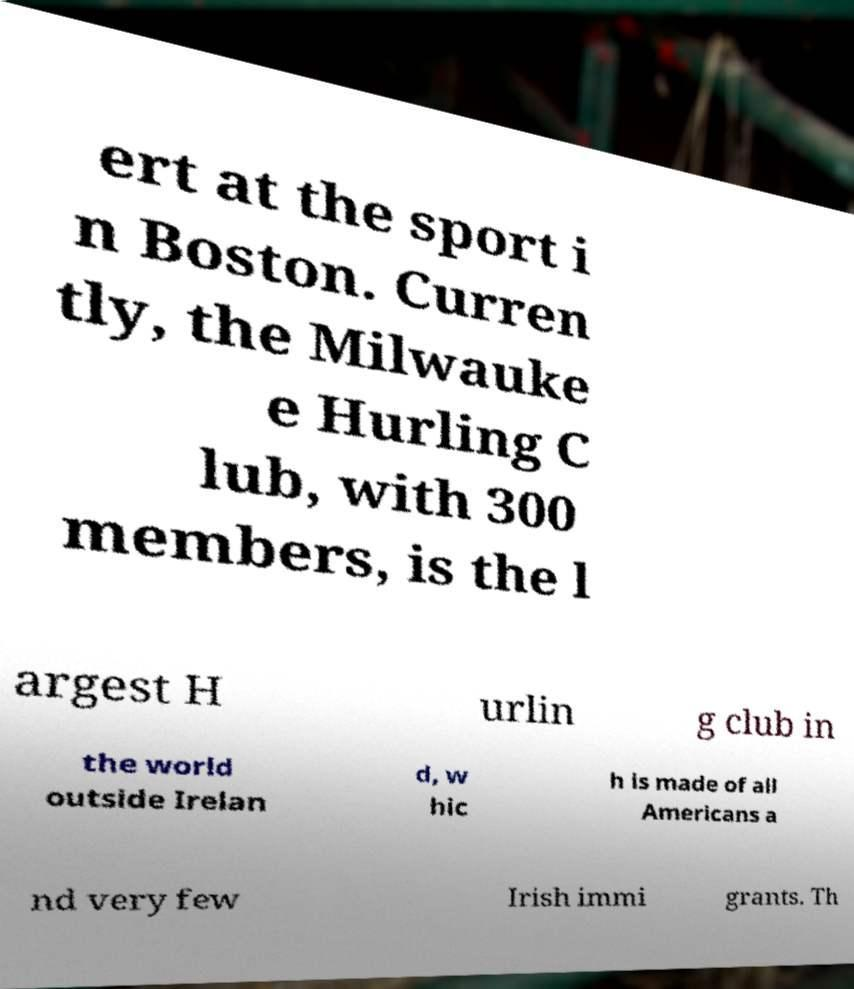There's text embedded in this image that I need extracted. Can you transcribe it verbatim? ert at the sport i n Boston. Curren tly, the Milwauke e Hurling C lub, with 300 members, is the l argest H urlin g club in the world outside Irelan d, w hic h is made of all Americans a nd very few Irish immi grants. Th 